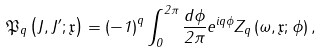Convert formula to latex. <formula><loc_0><loc_0><loc_500><loc_500>\mathfrak { P } _ { q } \left ( J , J ^ { \prime } ; \mathfrak { x } \right ) = \left ( - 1 \right ) ^ { q } \int _ { 0 } ^ { 2 \pi } \frac { d \phi } { 2 \pi } e ^ { i q \phi } Z _ { q } \left ( \omega , \mathfrak { x } ; \phi \right ) ,</formula> 